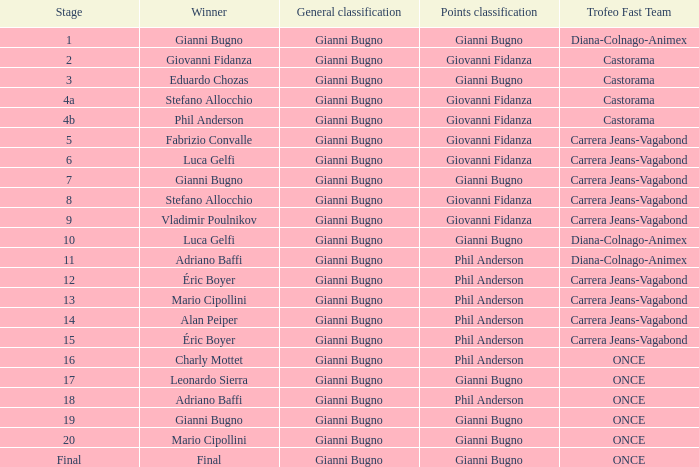Who is the points classification in stage 1? Gianni Bugno. 